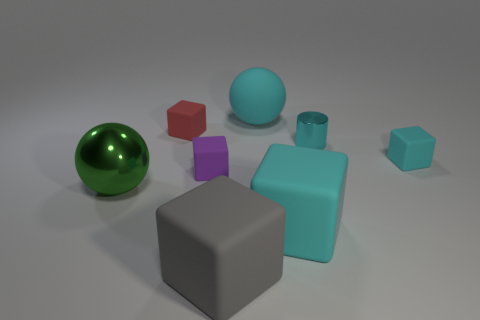Subtract all cyan blocks. How many were subtracted if there are1cyan blocks left? 1 Subtract all small cyan blocks. How many blocks are left? 4 Subtract all red cubes. How many cubes are left? 4 Add 2 big yellow spheres. How many objects exist? 10 Subtract 4 cubes. How many cubes are left? 1 Add 7 gray things. How many gray things exist? 8 Subtract 0 purple spheres. How many objects are left? 8 Subtract all cubes. How many objects are left? 3 Subtract all purple cylinders. Subtract all green balls. How many cylinders are left? 1 Subtract all blue balls. How many blue cylinders are left? 0 